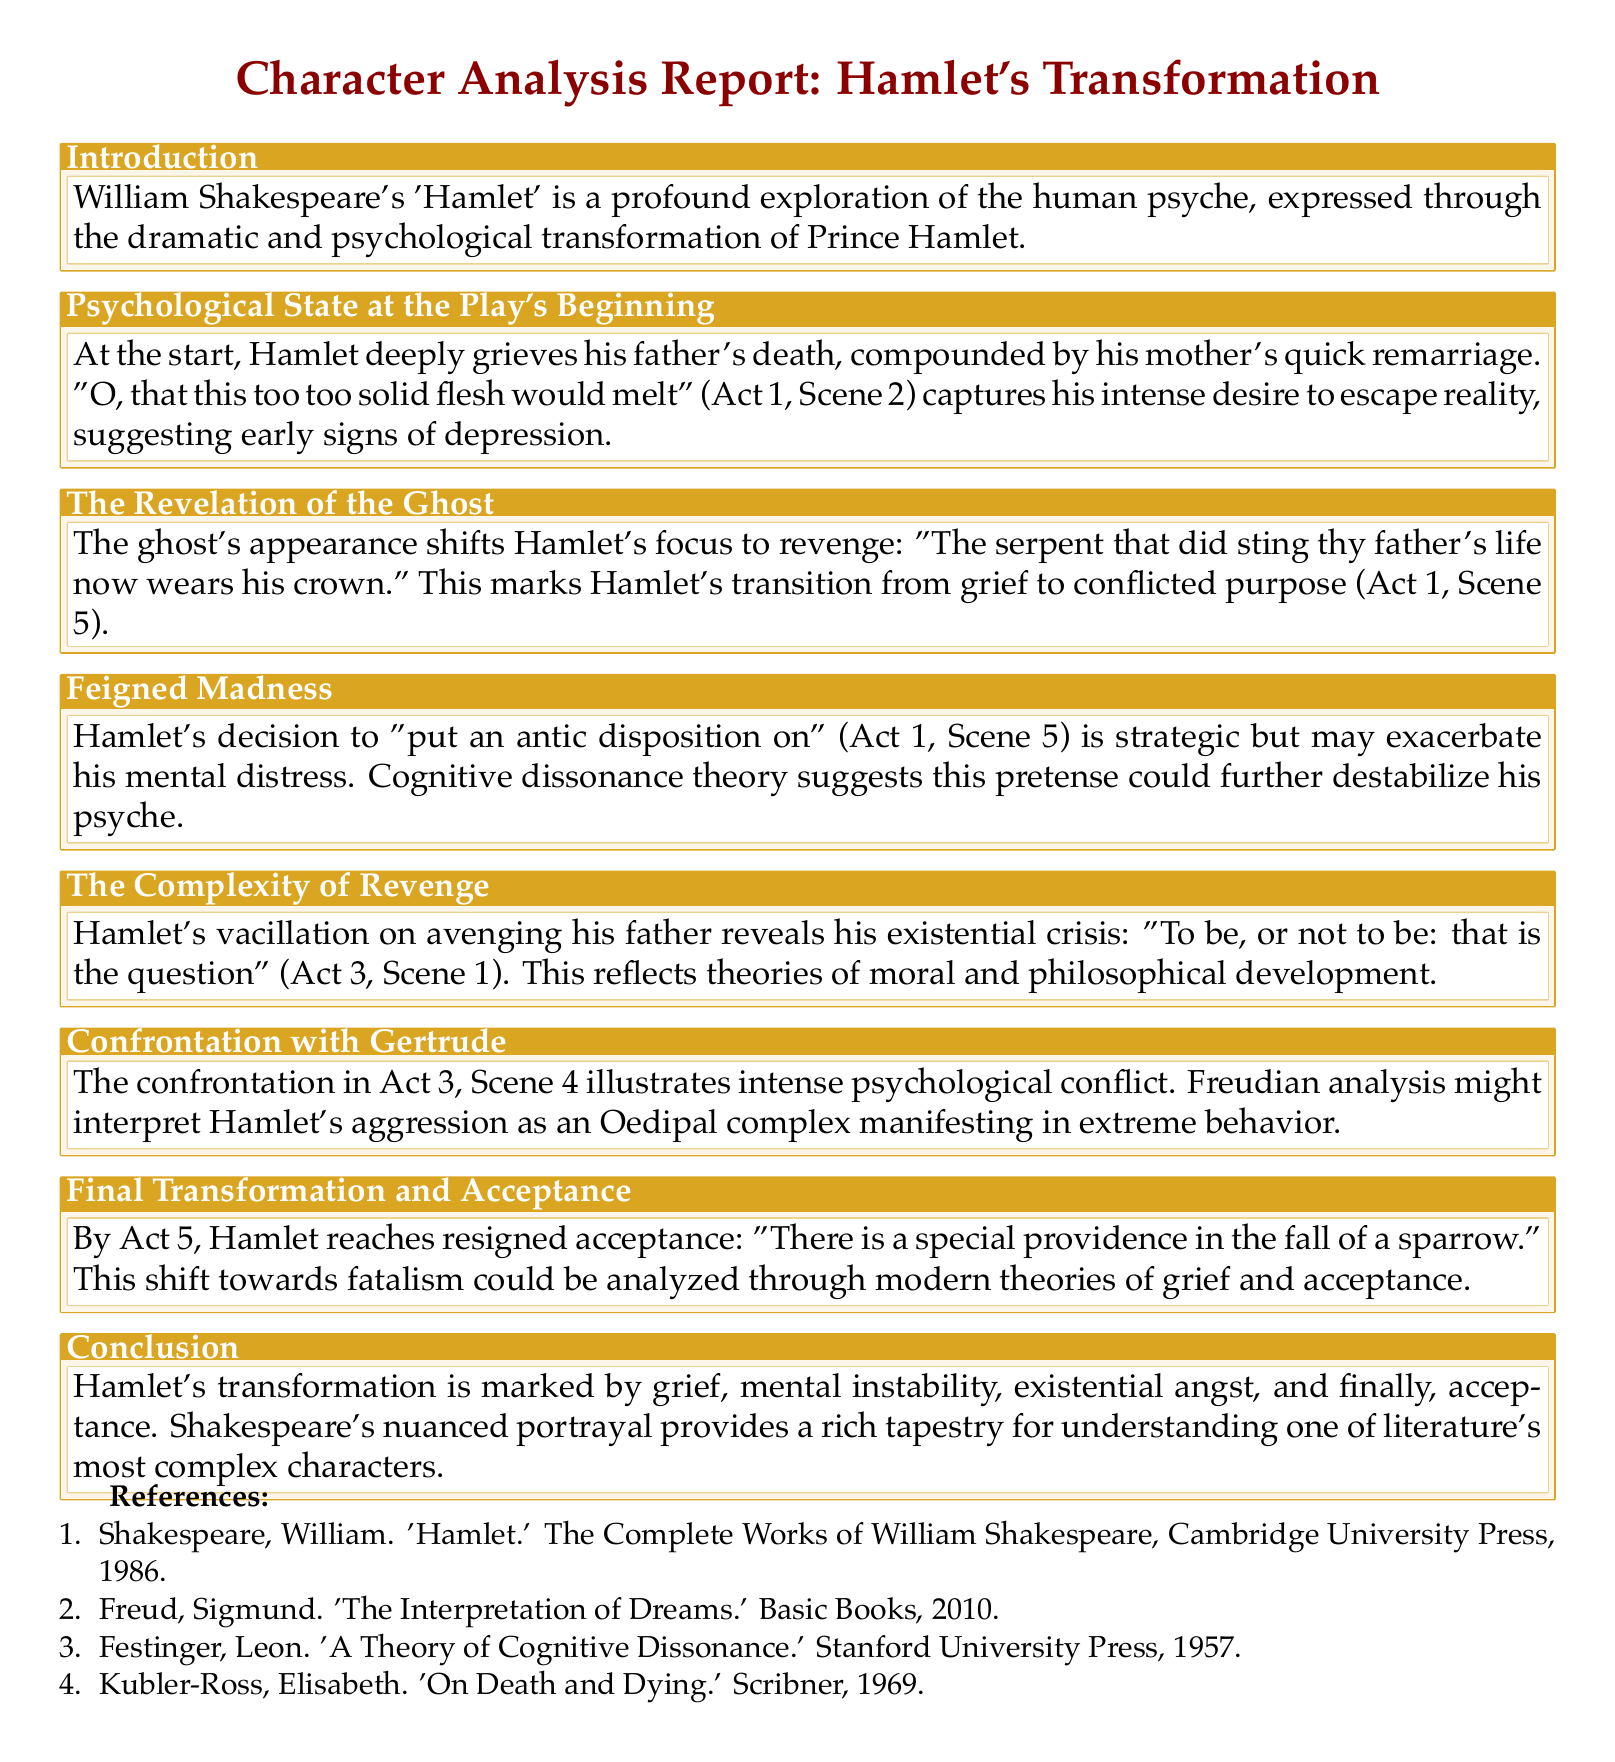What is the title of the document? The title is the main heading of the document, which summarizes its content.
Answer: Character Analysis Report: Hamlet's Transformation Who is the author of 'Hamlet'? The document references the author of 'Hamlet' within the content.
Answer: William Shakespeare In which act does Hamlet say, "To be, or not to be"? The act is specified in the content where the quote is analyzed.
Answer: Act 3 What psychological theory is mentioned in relation to Hamlet's feigned madness? The theory is specifically referenced within the context of Hamlet's actions and mental state.
Answer: Cognitive dissonance theory What is Hamlet's final acceptance phrase? The final phrase summarizes Hamlet's resigned acceptance in the document.
Answer: "There is a special providence in the fall of a sparrow." What type of psychological conflict is illustrated in Act 3, Scene 4? The type of conflict is mentioned in reference to Hamlet's confrontation with Gertrude.
Answer: Oedipal complex What marks the transition of Hamlet's focus to revenge? This transition is addressed through a specific event in the play outlined in the document.
Answer: The ghost's appearance How many references are listed in the document? The number of references is found at the end of the document, enumerating sources.
Answer: Four 